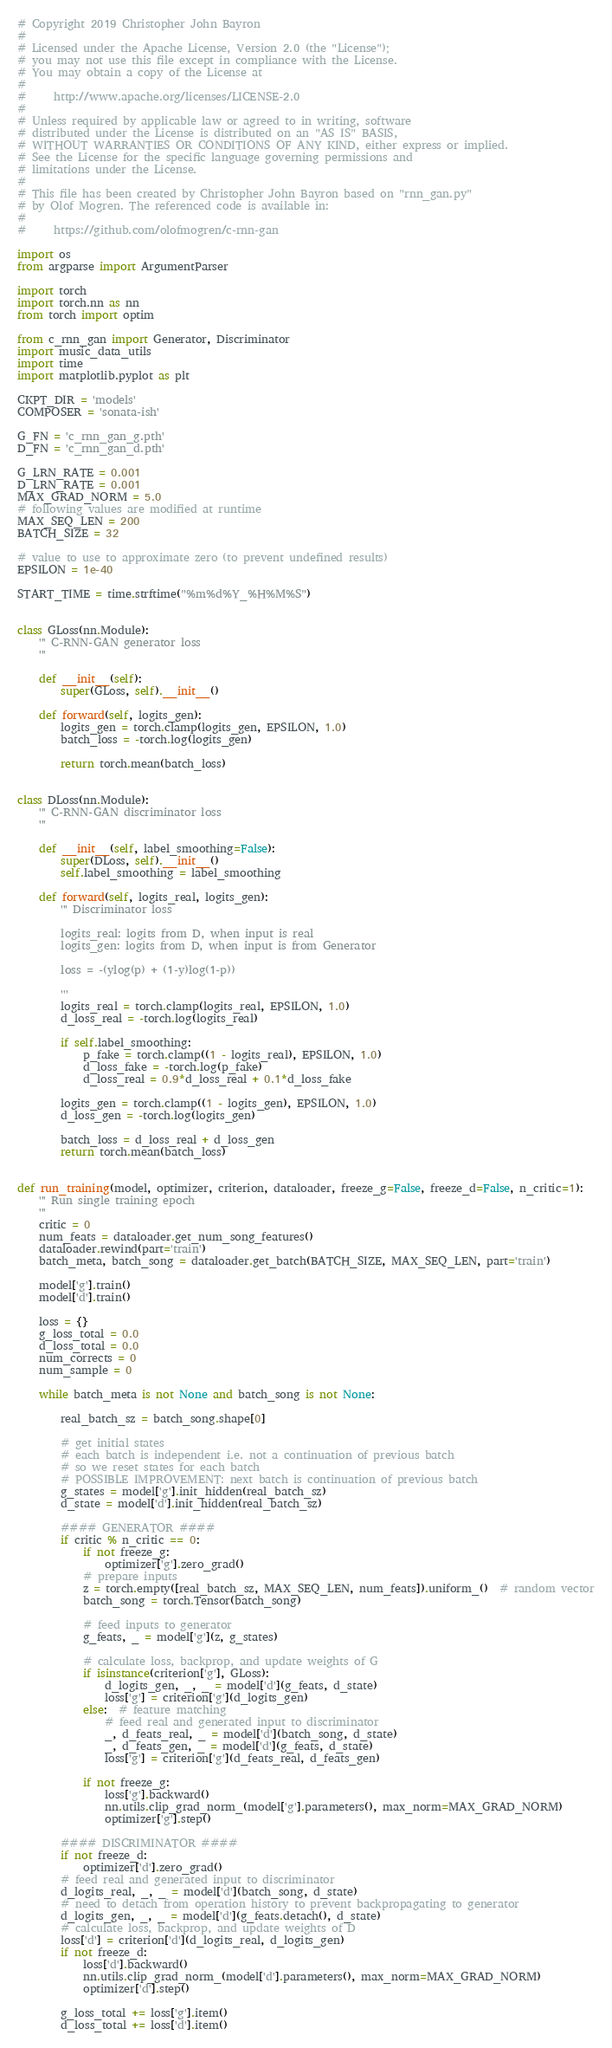Convert code to text. <code><loc_0><loc_0><loc_500><loc_500><_Python_># Copyright 2019 Christopher John Bayron
#
# Licensed under the Apache License, Version 2.0 (the "License");
# you may not use this file except in compliance with the License.
# You may obtain a copy of the License at
#
#     http://www.apache.org/licenses/LICENSE-2.0
#
# Unless required by applicable law or agreed to in writing, software
# distributed under the License is distributed on an "AS IS" BASIS,
# WITHOUT WARRANTIES OR CONDITIONS OF ANY KIND, either express or implied.
# See the License for the specific language governing permissions and
# limitations under the License.
#
# This file has been created by Christopher John Bayron based on "rnn_gan.py"
# by Olof Mogren. The referenced code is available in:
#
#     https://github.com/olofmogren/c-rnn-gan

import os
from argparse import ArgumentParser

import torch
import torch.nn as nn
from torch import optim

from c_rnn_gan import Generator, Discriminator
import music_data_utils
import time
import matplotlib.pyplot as plt

CKPT_DIR = 'models'
COMPOSER = 'sonata-ish'

G_FN = 'c_rnn_gan_g.pth'
D_FN = 'c_rnn_gan_d.pth'

G_LRN_RATE = 0.001
D_LRN_RATE = 0.001
MAX_GRAD_NORM = 5.0
# following values are modified at runtime
MAX_SEQ_LEN = 200
BATCH_SIZE = 32

# value to use to approximate zero (to prevent undefined results)
EPSILON = 1e-40

START_TIME = time.strftime("%m%d%Y_%H%M%S")


class GLoss(nn.Module):
    ''' C-RNN-GAN generator loss
    '''

    def __init__(self):
        super(GLoss, self).__init__()

    def forward(self, logits_gen):
        logits_gen = torch.clamp(logits_gen, EPSILON, 1.0)
        batch_loss = -torch.log(logits_gen)

        return torch.mean(batch_loss)


class DLoss(nn.Module):
    ''' C-RNN-GAN discriminator loss
    '''

    def __init__(self, label_smoothing=False):
        super(DLoss, self).__init__()
        self.label_smoothing = label_smoothing

    def forward(self, logits_real, logits_gen):
        ''' Discriminator loss

        logits_real: logits from D, when input is real
        logits_gen: logits from D, when input is from Generator

        loss = -(ylog(p) + (1-y)log(1-p))

        '''
        logits_real = torch.clamp(logits_real, EPSILON, 1.0)
        d_loss_real = -torch.log(logits_real)

        if self.label_smoothing:
            p_fake = torch.clamp((1 - logits_real), EPSILON, 1.0)
            d_loss_fake = -torch.log(p_fake)
            d_loss_real = 0.9*d_loss_real + 0.1*d_loss_fake

        logits_gen = torch.clamp((1 - logits_gen), EPSILON, 1.0)
        d_loss_gen = -torch.log(logits_gen)

        batch_loss = d_loss_real + d_loss_gen
        return torch.mean(batch_loss)


def run_training(model, optimizer, criterion, dataloader, freeze_g=False, freeze_d=False, n_critic=1):
    ''' Run single training epoch
    '''
    critic = 0
    num_feats = dataloader.get_num_song_features()
    dataloader.rewind(part='train')
    batch_meta, batch_song = dataloader.get_batch(BATCH_SIZE, MAX_SEQ_LEN, part='train')

    model['g'].train()
    model['d'].train()

    loss = {}
    g_loss_total = 0.0
    d_loss_total = 0.0
    num_corrects = 0
    num_sample = 0

    while batch_meta is not None and batch_song is not None:

        real_batch_sz = batch_song.shape[0]

        # get initial states
        # each batch is independent i.e. not a continuation of previous batch
        # so we reset states for each batch
        # POSSIBLE IMPROVEMENT: next batch is continuation of previous batch
        g_states = model['g'].init_hidden(real_batch_sz)
        d_state = model['d'].init_hidden(real_batch_sz)

        #### GENERATOR ####
        if critic % n_critic == 0:
            if not freeze_g:
                optimizer['g'].zero_grad()
            # prepare inputs
            z = torch.empty([real_batch_sz, MAX_SEQ_LEN, num_feats]).uniform_()  # random vector
            batch_song = torch.Tensor(batch_song)

            # feed inputs to generator
            g_feats, _ = model['g'](z, g_states)

            # calculate loss, backprop, and update weights of G
            if isinstance(criterion['g'], GLoss):
                d_logits_gen, _, _ = model['d'](g_feats, d_state)
                loss['g'] = criterion['g'](d_logits_gen)
            else:  # feature matching
                # feed real and generated input to discriminator
                _, d_feats_real, _ = model['d'](batch_song, d_state)
                _, d_feats_gen, _ = model['d'](g_feats, d_state)
                loss['g'] = criterion['g'](d_feats_real, d_feats_gen)

            if not freeze_g:
                loss['g'].backward()
                nn.utils.clip_grad_norm_(model['g'].parameters(), max_norm=MAX_GRAD_NORM)
                optimizer['g'].step()

        #### DISCRIMINATOR ####
        if not freeze_d:
            optimizer['d'].zero_grad()
        # feed real and generated input to discriminator
        d_logits_real, _, _ = model['d'](batch_song, d_state)
        # need to detach from operation history to prevent backpropagating to generator
        d_logits_gen, _, _ = model['d'](g_feats.detach(), d_state)
        # calculate loss, backprop, and update weights of D
        loss['d'] = criterion['d'](d_logits_real, d_logits_gen)
        if not freeze_d:
            loss['d'].backward()
            nn.utils.clip_grad_norm_(model['d'].parameters(), max_norm=MAX_GRAD_NORM)
            optimizer['d'].step()

        g_loss_total += loss['g'].item()
        d_loss_total += loss['d'].item()</code> 